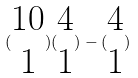<formula> <loc_0><loc_0><loc_500><loc_500>( \begin{matrix} 1 0 \\ 1 \end{matrix} ) ( \begin{matrix} 4 \\ 1 \end{matrix} ) - ( \begin{matrix} 4 \\ 1 \end{matrix} )</formula> 